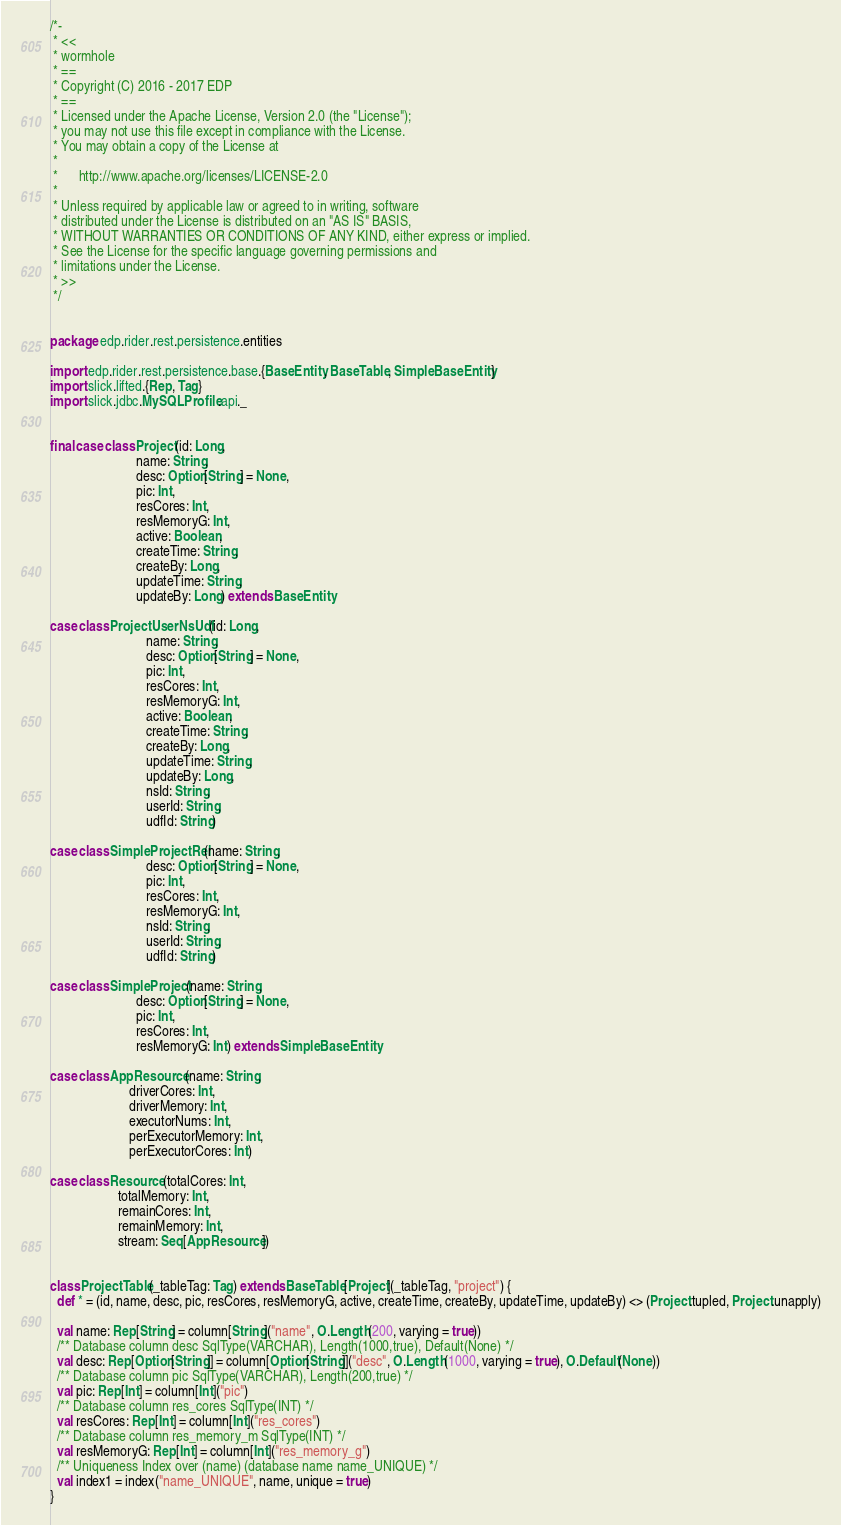Convert code to text. <code><loc_0><loc_0><loc_500><loc_500><_Scala_>/*-
 * <<
 * wormhole
 * ==
 * Copyright (C) 2016 - 2017 EDP
 * ==
 * Licensed under the Apache License, Version 2.0 (the "License");
 * you may not use this file except in compliance with the License.
 * You may obtain a copy of the License at
 * 
 *      http://www.apache.org/licenses/LICENSE-2.0
 * 
 * Unless required by applicable law or agreed to in writing, software
 * distributed under the License is distributed on an "AS IS" BASIS,
 * WITHOUT WARRANTIES OR CONDITIONS OF ANY KIND, either express or implied.
 * See the License for the specific language governing permissions and
 * limitations under the License.
 * >>
 */


package edp.rider.rest.persistence.entities

import edp.rider.rest.persistence.base.{BaseEntity, BaseTable, SimpleBaseEntity}
import slick.lifted.{Rep, Tag}
import slick.jdbc.MySQLProfile.api._


final case class Project(id: Long,
                         name: String,
                         desc: Option[String] = None,
                         pic: Int,
                         resCores: Int,
                         resMemoryG: Int,
                         active: Boolean,
                         createTime: String,
                         createBy: Long,
                         updateTime: String,
                         updateBy: Long) extends BaseEntity

case class ProjectUserNsUdf(id: Long,
                            name: String,
                            desc: Option[String] = None,
                            pic: Int,
                            resCores: Int,
                            resMemoryG: Int,
                            active: Boolean,
                            createTime: String,
                            createBy: Long,
                            updateTime: String,
                            updateBy: Long,
                            nsId: String,
                            userId: String,
                            udfId: String)

case class SimpleProjectRel(name: String,
                            desc: Option[String] = None,
                            pic: Int,
                            resCores: Int,
                            resMemoryG: Int,
                            nsId: String,
                            userId: String,
                            udfId: String)

case class SimpleProject(name: String,
                         desc: Option[String] = None,
                         pic: Int,
                         resCores: Int,
                         resMemoryG: Int) extends SimpleBaseEntity

case class AppResource(name: String,
                       driverCores: Int,
                       driverMemory: Int,
                       executorNums: Int,
                       perExecutorMemory: Int,
                       perExecutorCores: Int)

case class Resource(totalCores: Int,
                    totalMemory: Int,
                    remainCores: Int,
                    remainMemory: Int,
                    stream: Seq[AppResource])


class ProjectTable(_tableTag: Tag) extends BaseTable[Project](_tableTag, "project") {
  def * = (id, name, desc, pic, resCores, resMemoryG, active, createTime, createBy, updateTime, updateBy) <> (Project.tupled, Project.unapply)

  val name: Rep[String] = column[String]("name", O.Length(200, varying = true))
  /** Database column desc SqlType(VARCHAR), Length(1000,true), Default(None) */
  val desc: Rep[Option[String]] = column[Option[String]]("desc", O.Length(1000, varying = true), O.Default(None))
  /** Database column pic SqlType(VARCHAR), Length(200,true) */
  val pic: Rep[Int] = column[Int]("pic")
  /** Database column res_cores SqlType(INT) */
  val resCores: Rep[Int] = column[Int]("res_cores")
  /** Database column res_memory_m SqlType(INT) */
  val resMemoryG: Rep[Int] = column[Int]("res_memory_g")
  /** Uniqueness Index over (name) (database name name_UNIQUE) */
  val index1 = index("name_UNIQUE", name, unique = true)
}
</code> 